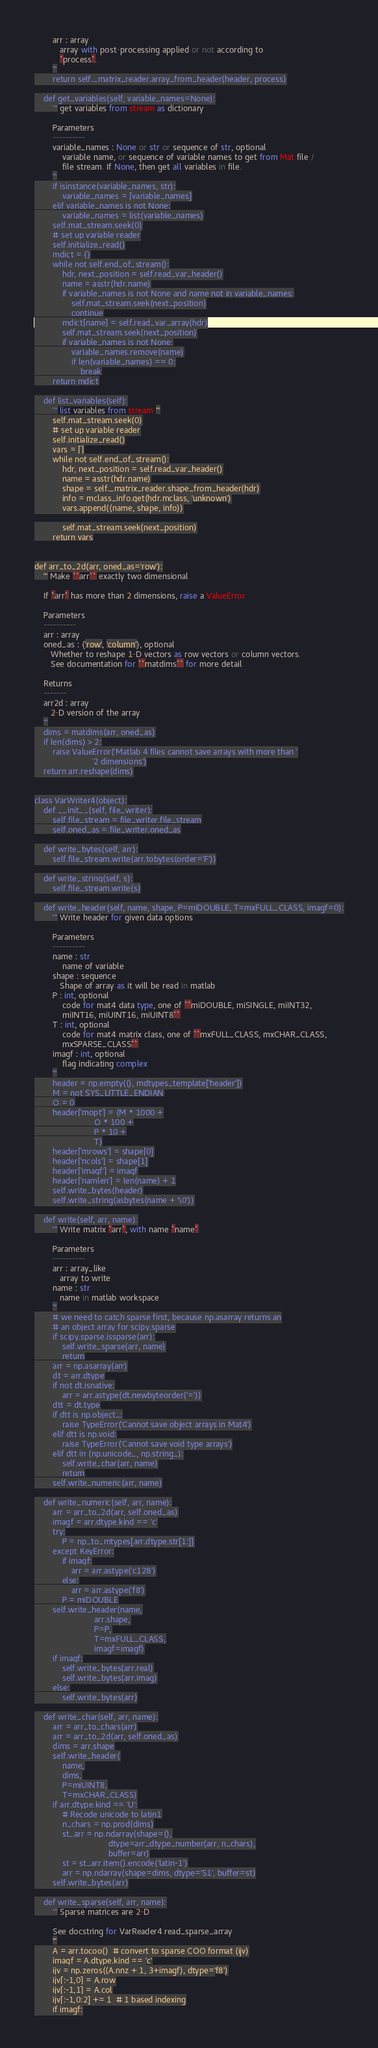<code> <loc_0><loc_0><loc_500><loc_500><_Python_>        arr : array
           array with post-processing applied or not according to
           `process`.
        '''
        return self._matrix_reader.array_from_header(header, process)

    def get_variables(self, variable_names=None):
        ''' get variables from stream as dictionary

        Parameters
        ----------
        variable_names : None or str or sequence of str, optional
            variable name, or sequence of variable names to get from Mat file /
            file stream. If None, then get all variables in file.
        '''
        if isinstance(variable_names, str):
            variable_names = [variable_names]
        elif variable_names is not None:
            variable_names = list(variable_names)
        self.mat_stream.seek(0)
        # set up variable reader
        self.initialize_read()
        mdict = {}
        while not self.end_of_stream():
            hdr, next_position = self.read_var_header()
            name = asstr(hdr.name)
            if variable_names is not None and name not in variable_names:
                self.mat_stream.seek(next_position)
                continue
            mdict[name] = self.read_var_array(hdr)
            self.mat_stream.seek(next_position)
            if variable_names is not None:
                variable_names.remove(name)
                if len(variable_names) == 0:
                    break
        return mdict

    def list_variables(self):
        ''' list variables from stream '''
        self.mat_stream.seek(0)
        # set up variable reader
        self.initialize_read()
        vars = []
        while not self.end_of_stream():
            hdr, next_position = self.read_var_header()
            name = asstr(hdr.name)
            shape = self._matrix_reader.shape_from_header(hdr)
            info = mclass_info.get(hdr.mclass, 'unknown')
            vars.append((name, shape, info))

            self.mat_stream.seek(next_position)
        return vars


def arr_to_2d(arr, oned_as='row'):
    ''' Make ``arr`` exactly two dimensional

    If `arr` has more than 2 dimensions, raise a ValueError

    Parameters
    ----------
    arr : array
    oned_as : {'row', 'column'}, optional
       Whether to reshape 1-D vectors as row vectors or column vectors.
       See documentation for ``matdims`` for more detail

    Returns
    -------
    arr2d : array
       2-D version of the array
    '''
    dims = matdims(arr, oned_as)
    if len(dims) > 2:
        raise ValueError('Matlab 4 files cannot save arrays with more than '
                         '2 dimensions')
    return arr.reshape(dims)


class VarWriter4(object):
    def __init__(self, file_writer):
        self.file_stream = file_writer.file_stream
        self.oned_as = file_writer.oned_as

    def write_bytes(self, arr):
        self.file_stream.write(arr.tobytes(order='F'))

    def write_string(self, s):
        self.file_stream.write(s)

    def write_header(self, name, shape, P=miDOUBLE, T=mxFULL_CLASS, imagf=0):
        ''' Write header for given data options

        Parameters
        ----------
        name : str
            name of variable
        shape : sequence
           Shape of array as it will be read in matlab
        P : int, optional
            code for mat4 data type, one of ``miDOUBLE, miSINGLE, miINT32,
            miINT16, miUINT16, miUINT8``
        T : int, optional
            code for mat4 matrix class, one of ``mxFULL_CLASS, mxCHAR_CLASS,
            mxSPARSE_CLASS``
        imagf : int, optional
            flag indicating complex
        '''
        header = np.empty((), mdtypes_template['header'])
        M = not SYS_LITTLE_ENDIAN
        O = 0
        header['mopt'] = (M * 1000 +
                          O * 100 +
                          P * 10 +
                          T)
        header['mrows'] = shape[0]
        header['ncols'] = shape[1]
        header['imagf'] = imagf
        header['namlen'] = len(name) + 1
        self.write_bytes(header)
        self.write_string(asbytes(name + '\0'))

    def write(self, arr, name):
        ''' Write matrix `arr`, with name `name`

        Parameters
        ----------
        arr : array_like
           array to write
        name : str
           name in matlab workspace
        '''
        # we need to catch sparse first, because np.asarray returns an
        # an object array for scipy.sparse
        if scipy.sparse.issparse(arr):
            self.write_sparse(arr, name)
            return
        arr = np.asarray(arr)
        dt = arr.dtype
        if not dt.isnative:
            arr = arr.astype(dt.newbyteorder('='))
        dtt = dt.type
        if dtt is np.object_:
            raise TypeError('Cannot save object arrays in Mat4')
        elif dtt is np.void:
            raise TypeError('Cannot save void type arrays')
        elif dtt in (np.unicode_, np.string_):
            self.write_char(arr, name)
            return
        self.write_numeric(arr, name)

    def write_numeric(self, arr, name):
        arr = arr_to_2d(arr, self.oned_as)
        imagf = arr.dtype.kind == 'c'
        try:
            P = np_to_mtypes[arr.dtype.str[1:]]
        except KeyError:
            if imagf:
                arr = arr.astype('c128')
            else:
                arr = arr.astype('f8')
            P = miDOUBLE
        self.write_header(name,
                          arr.shape,
                          P=P,
                          T=mxFULL_CLASS,
                          imagf=imagf)
        if imagf:
            self.write_bytes(arr.real)
            self.write_bytes(arr.imag)
        else:
            self.write_bytes(arr)

    def write_char(self, arr, name):
        arr = arr_to_chars(arr)
        arr = arr_to_2d(arr, self.oned_as)
        dims = arr.shape
        self.write_header(
            name,
            dims,
            P=miUINT8,
            T=mxCHAR_CLASS)
        if arr.dtype.kind == 'U':
            # Recode unicode to latin1
            n_chars = np.prod(dims)
            st_arr = np.ndarray(shape=(),
                                dtype=arr_dtype_number(arr, n_chars),
                                buffer=arr)
            st = st_arr.item().encode('latin-1')
            arr = np.ndarray(shape=dims, dtype='S1', buffer=st)
        self.write_bytes(arr)

    def write_sparse(self, arr, name):
        ''' Sparse matrices are 2-D

        See docstring for VarReader4.read_sparse_array
        '''
        A = arr.tocoo()  # convert to sparse COO format (ijv)
        imagf = A.dtype.kind == 'c'
        ijv = np.zeros((A.nnz + 1, 3+imagf), dtype='f8')
        ijv[:-1,0] = A.row
        ijv[:-1,1] = A.col
        ijv[:-1,0:2] += 1  # 1 based indexing
        if imagf:</code> 